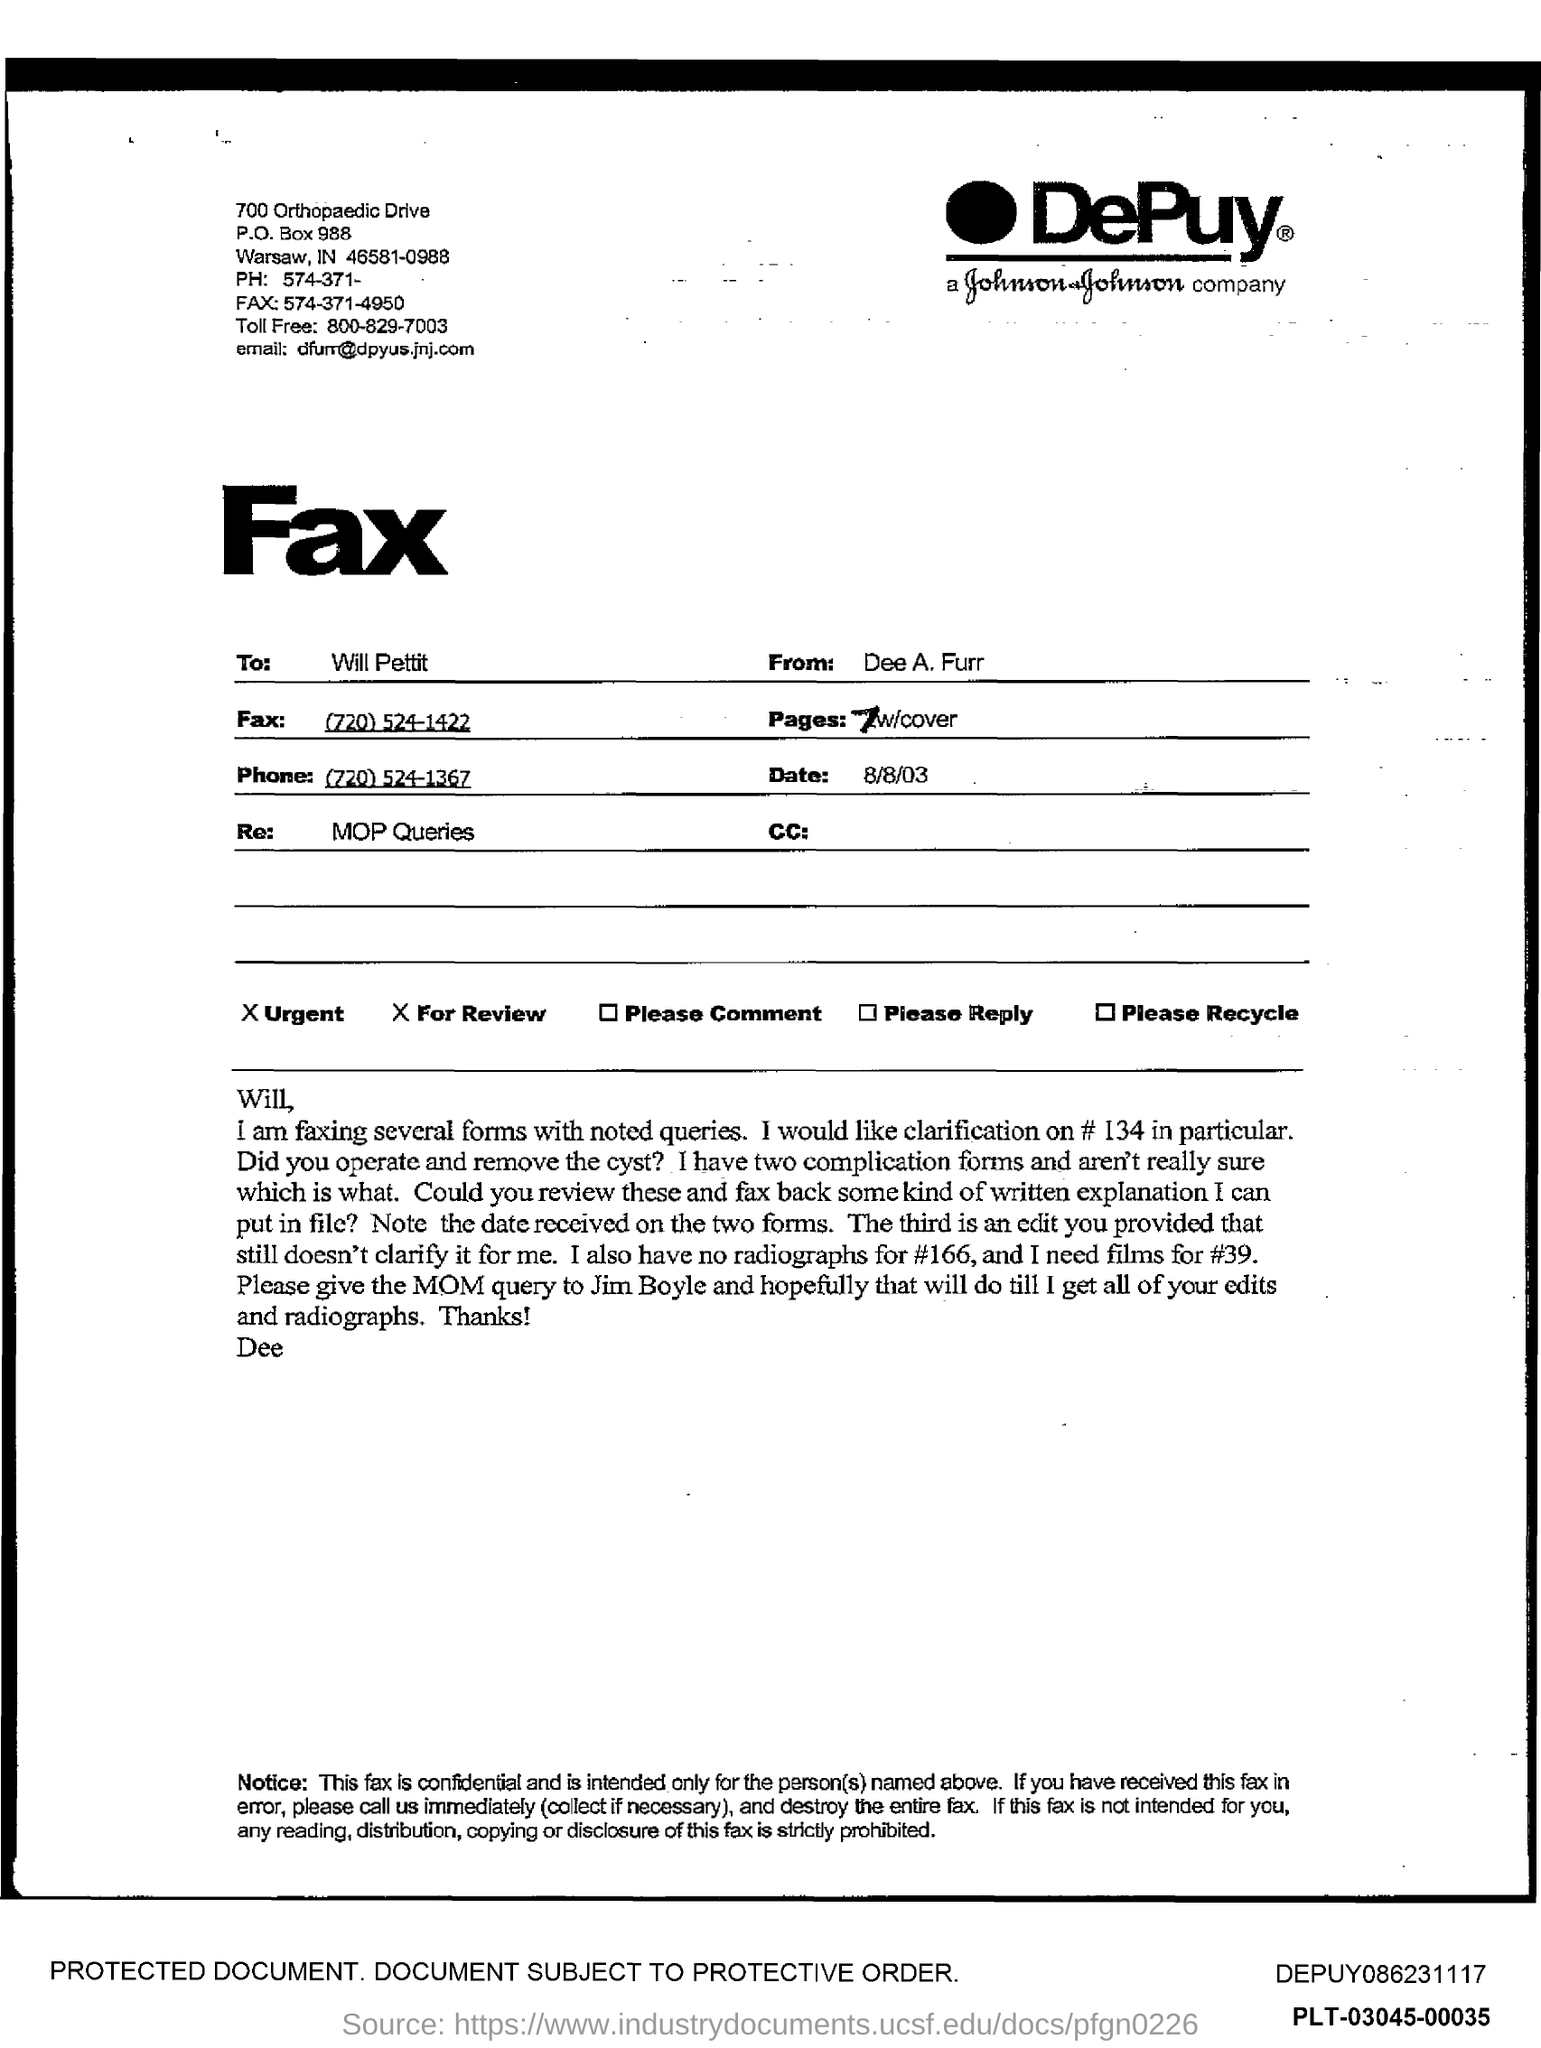Can you provide more details about the nature of the queries mentioned in the fax? The fax mentions several forms with queries needing clarification, specifically regarding a surgical operation involving a cyst removal and related complications. It seeks further written clarifications to better understand the procedures and outcomes. What might be the purpose of such correspondence? Such correspondence is essential for medical operations to ensure all procedural aspects are clear and documented. This helps in managing patient care effectively and adhering to legal and medical standards. 